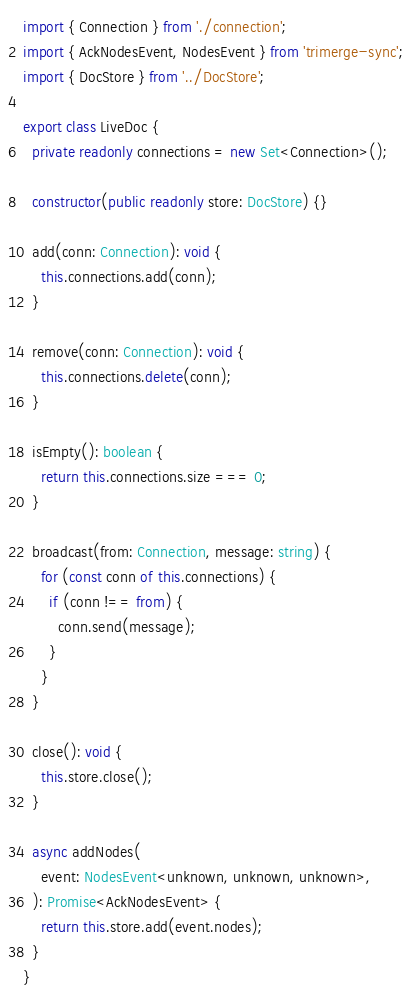<code> <loc_0><loc_0><loc_500><loc_500><_TypeScript_>import { Connection } from './connection';
import { AckNodesEvent, NodesEvent } from 'trimerge-sync';
import { DocStore } from '../DocStore';

export class LiveDoc {
  private readonly connections = new Set<Connection>();

  constructor(public readonly store: DocStore) {}

  add(conn: Connection): void {
    this.connections.add(conn);
  }

  remove(conn: Connection): void {
    this.connections.delete(conn);
  }

  isEmpty(): boolean {
    return this.connections.size === 0;
  }

  broadcast(from: Connection, message: string) {
    for (const conn of this.connections) {
      if (conn !== from) {
        conn.send(message);
      }
    }
  }

  close(): void {
    this.store.close();
  }

  async addNodes(
    event: NodesEvent<unknown, unknown, unknown>,
  ): Promise<AckNodesEvent> {
    return this.store.add(event.nodes);
  }
}
</code> 